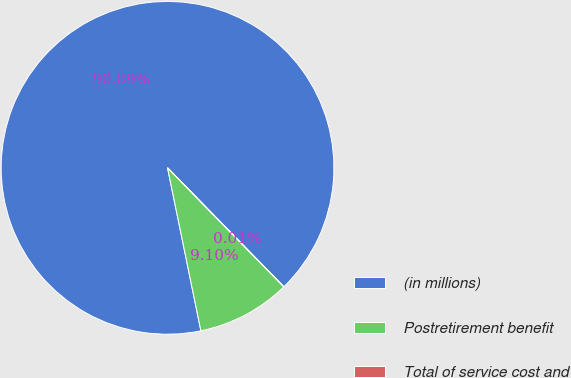Convert chart. <chart><loc_0><loc_0><loc_500><loc_500><pie_chart><fcel>(in millions)<fcel>Postretirement benefit<fcel>Total of service cost and<nl><fcel>90.89%<fcel>9.1%<fcel>0.01%<nl></chart> 